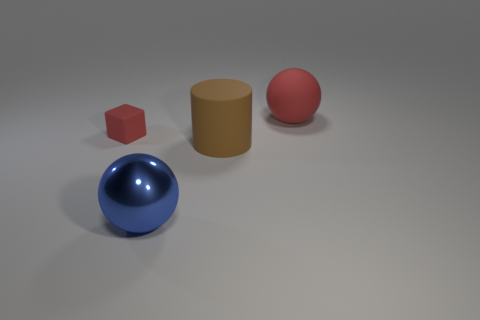There is another big red object that is the same shape as the metallic thing; what material is it?
Ensure brevity in your answer.  Rubber. Is there anything else that is made of the same material as the big blue sphere?
Offer a terse response. No. What number of objects are either objects in front of the brown cylinder or large red matte spheres?
Keep it short and to the point. 2. How big is the rubber thing left of the big brown rubber cylinder?
Keep it short and to the point. Small. What material is the cube?
Make the answer very short. Rubber. What shape is the large blue object on the right side of the matte object that is to the left of the big metal sphere?
Offer a terse response. Sphere. What number of other objects are there of the same shape as the large blue metal object?
Provide a short and direct response. 1. Are there any blocks left of the rubber sphere?
Give a very brief answer. Yes. What is the color of the block?
Provide a succinct answer. Red. There is a rubber block; is it the same color as the large sphere behind the shiny object?
Offer a very short reply. Yes. 